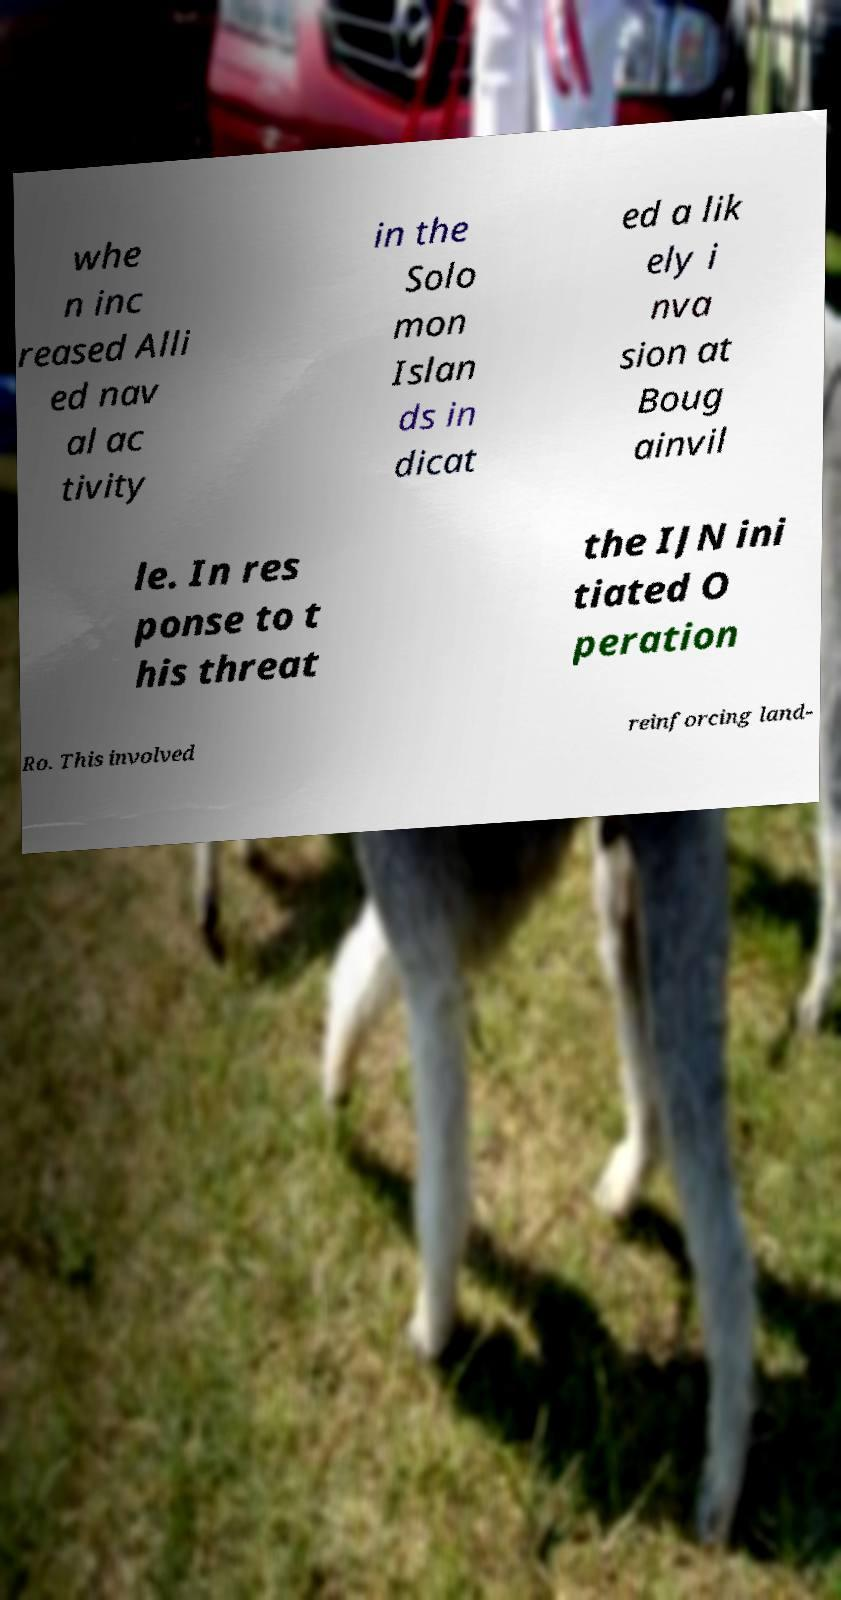Can you accurately transcribe the text from the provided image for me? whe n inc reased Alli ed nav al ac tivity in the Solo mon Islan ds in dicat ed a lik ely i nva sion at Boug ainvil le. In res ponse to t his threat the IJN ini tiated O peration Ro. This involved reinforcing land- 